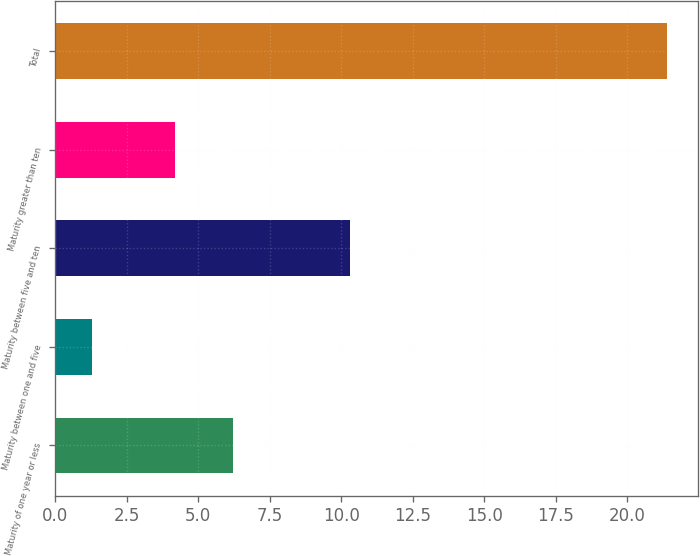Convert chart. <chart><loc_0><loc_0><loc_500><loc_500><bar_chart><fcel>Maturity of one year or less<fcel>Maturity between one and five<fcel>Maturity between five and ten<fcel>Maturity greater than ten<fcel>Total<nl><fcel>6.21<fcel>1.3<fcel>10.3<fcel>4.2<fcel>21.4<nl></chart> 